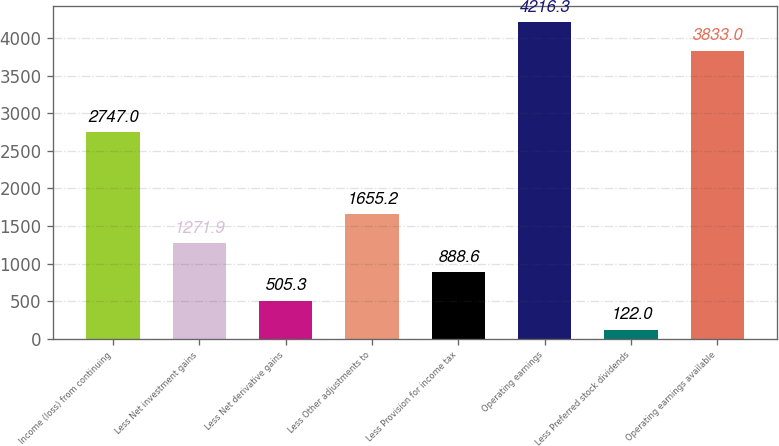Convert chart. <chart><loc_0><loc_0><loc_500><loc_500><bar_chart><fcel>Income (loss) from continuing<fcel>Less Net investment gains<fcel>Less Net derivative gains<fcel>Less Other adjustments to<fcel>Less Provision for income tax<fcel>Operating earnings<fcel>Less Preferred stock dividends<fcel>Operating earnings available<nl><fcel>2747<fcel>1271.9<fcel>505.3<fcel>1655.2<fcel>888.6<fcel>4216.3<fcel>122<fcel>3833<nl></chart> 